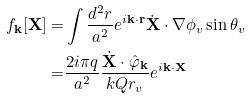Convert formula to latex. <formula><loc_0><loc_0><loc_500><loc_500>f _ { \mathbf k } [ \mathbf X ] = & \int \frac { d ^ { 2 } r } { a ^ { 2 } } e ^ { i \mathbf k \cdot \mathbf r } \dot { \mathbf X } \cdot \mathbf \nabla \phi _ { v } \sin \theta _ { v } \\ = & \frac { 2 i \pi q } { a ^ { 2 } } \frac { \dot { \mathbf X } \cdot \hat { \varphi } _ { \mathbf k } } { k Q r _ { v } } e ^ { i \mathbf k \cdot \mathbf X }</formula> 